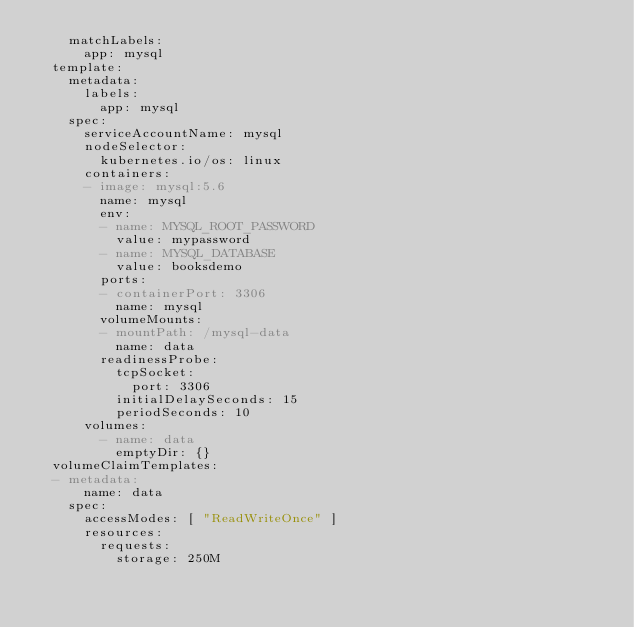Convert code to text. <code><loc_0><loc_0><loc_500><loc_500><_YAML_>    matchLabels:
      app: mysql
  template:
    metadata:
      labels:
        app: mysql
    spec:
      serviceAccountName: mysql
      nodeSelector:
        kubernetes.io/os: linux
      containers:
      - image: mysql:5.6
        name: mysql
        env:
        - name: MYSQL_ROOT_PASSWORD
          value: mypassword
        - name: MYSQL_DATABASE
          value: booksdemo
        ports:
        - containerPort: 3306
          name: mysql
        volumeMounts:
        - mountPath: /mysql-data
          name: data
        readinessProbe:
          tcpSocket:
            port: 3306
          initialDelaySeconds: 15
          periodSeconds: 10
      volumes:
        - name: data
          emptyDir: {}
  volumeClaimTemplates:
  - metadata:
      name: data
    spec:
      accessModes: [ "ReadWriteOnce" ]
      resources:
        requests:
          storage: 250M
</code> 